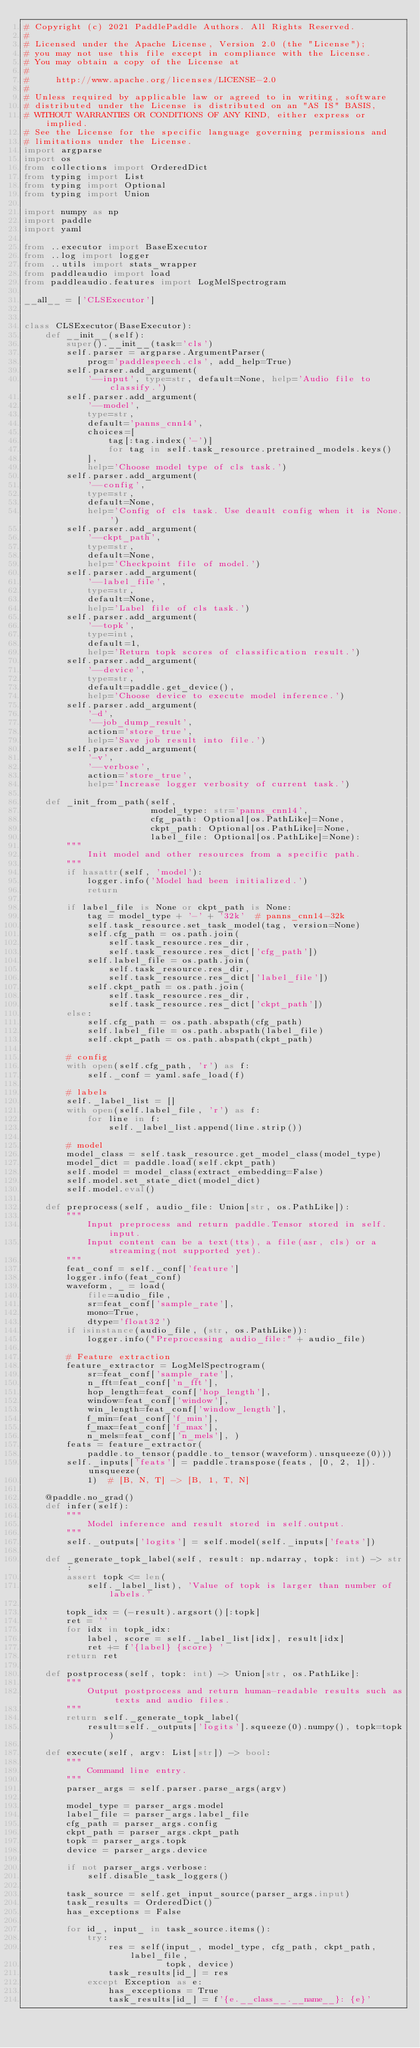<code> <loc_0><loc_0><loc_500><loc_500><_Python_># Copyright (c) 2021 PaddlePaddle Authors. All Rights Reserved.
#
# Licensed under the Apache License, Version 2.0 (the "License");
# you may not use this file except in compliance with the License.
# You may obtain a copy of the License at
#
#     http://www.apache.org/licenses/LICENSE-2.0
#
# Unless required by applicable law or agreed to in writing, software
# distributed under the License is distributed on an "AS IS" BASIS,
# WITHOUT WARRANTIES OR CONDITIONS OF ANY KIND, either express or implied.
# See the License for the specific language governing permissions and
# limitations under the License.
import argparse
import os
from collections import OrderedDict
from typing import List
from typing import Optional
from typing import Union

import numpy as np
import paddle
import yaml

from ..executor import BaseExecutor
from ..log import logger
from ..utils import stats_wrapper
from paddleaudio import load
from paddleaudio.features import LogMelSpectrogram

__all__ = ['CLSExecutor']


class CLSExecutor(BaseExecutor):
    def __init__(self):
        super().__init__(task='cls')
        self.parser = argparse.ArgumentParser(
            prog='paddlespeech.cls', add_help=True)
        self.parser.add_argument(
            '--input', type=str, default=None, help='Audio file to classify.')
        self.parser.add_argument(
            '--model',
            type=str,
            default='panns_cnn14',
            choices=[
                tag[:tag.index('-')]
                for tag in self.task_resource.pretrained_models.keys()
            ],
            help='Choose model type of cls task.')
        self.parser.add_argument(
            '--config',
            type=str,
            default=None,
            help='Config of cls task. Use deault config when it is None.')
        self.parser.add_argument(
            '--ckpt_path',
            type=str,
            default=None,
            help='Checkpoint file of model.')
        self.parser.add_argument(
            '--label_file',
            type=str,
            default=None,
            help='Label file of cls task.')
        self.parser.add_argument(
            '--topk',
            type=int,
            default=1,
            help='Return topk scores of classification result.')
        self.parser.add_argument(
            '--device',
            type=str,
            default=paddle.get_device(),
            help='Choose device to execute model inference.')
        self.parser.add_argument(
            '-d',
            '--job_dump_result',
            action='store_true',
            help='Save job result into file.')
        self.parser.add_argument(
            '-v',
            '--verbose',
            action='store_true',
            help='Increase logger verbosity of current task.')

    def _init_from_path(self,
                        model_type: str='panns_cnn14',
                        cfg_path: Optional[os.PathLike]=None,
                        ckpt_path: Optional[os.PathLike]=None,
                        label_file: Optional[os.PathLike]=None):
        """
            Init model and other resources from a specific path.
        """
        if hasattr(self, 'model'):
            logger.info('Model had been initialized.')
            return

        if label_file is None or ckpt_path is None:
            tag = model_type + '-' + '32k'  # panns_cnn14-32k
            self.task_resource.set_task_model(tag, version=None)
            self.cfg_path = os.path.join(
                self.task_resource.res_dir,
                self.task_resource.res_dict['cfg_path'])
            self.label_file = os.path.join(
                self.task_resource.res_dir,
                self.task_resource.res_dict['label_file'])
            self.ckpt_path = os.path.join(
                self.task_resource.res_dir,
                self.task_resource.res_dict['ckpt_path'])
        else:
            self.cfg_path = os.path.abspath(cfg_path)
            self.label_file = os.path.abspath(label_file)
            self.ckpt_path = os.path.abspath(ckpt_path)

        # config
        with open(self.cfg_path, 'r') as f:
            self._conf = yaml.safe_load(f)

        # labels
        self._label_list = []
        with open(self.label_file, 'r') as f:
            for line in f:
                self._label_list.append(line.strip())

        # model
        model_class = self.task_resource.get_model_class(model_type)
        model_dict = paddle.load(self.ckpt_path)
        self.model = model_class(extract_embedding=False)
        self.model.set_state_dict(model_dict)
        self.model.eval()

    def preprocess(self, audio_file: Union[str, os.PathLike]):
        """
            Input preprocess and return paddle.Tensor stored in self.input.
            Input content can be a text(tts), a file(asr, cls) or a streaming(not supported yet).
        """
        feat_conf = self._conf['feature']
        logger.info(feat_conf)
        waveform, _ = load(
            file=audio_file,
            sr=feat_conf['sample_rate'],
            mono=True,
            dtype='float32')
        if isinstance(audio_file, (str, os.PathLike)):
            logger.info("Preprocessing audio_file:" + audio_file)

        # Feature extraction
        feature_extractor = LogMelSpectrogram(
            sr=feat_conf['sample_rate'],
            n_fft=feat_conf['n_fft'],
            hop_length=feat_conf['hop_length'],
            window=feat_conf['window'],
            win_length=feat_conf['window_length'],
            f_min=feat_conf['f_min'],
            f_max=feat_conf['f_max'],
            n_mels=feat_conf['n_mels'], )
        feats = feature_extractor(
            paddle.to_tensor(paddle.to_tensor(waveform).unsqueeze(0)))
        self._inputs['feats'] = paddle.transpose(feats, [0, 2, 1]).unsqueeze(
            1)  # [B, N, T] -> [B, 1, T, N]

    @paddle.no_grad()
    def infer(self):
        """
            Model inference and result stored in self.output.
        """
        self._outputs['logits'] = self.model(self._inputs['feats'])

    def _generate_topk_label(self, result: np.ndarray, topk: int) -> str:
        assert topk <= len(
            self._label_list), 'Value of topk is larger than number of labels.'

        topk_idx = (-result).argsort()[:topk]
        ret = ''
        for idx in topk_idx:
            label, score = self._label_list[idx], result[idx]
            ret += f'{label} {score} '
        return ret

    def postprocess(self, topk: int) -> Union[str, os.PathLike]:
        """
            Output postprocess and return human-readable results such as texts and audio files.
        """
        return self._generate_topk_label(
            result=self._outputs['logits'].squeeze(0).numpy(), topk=topk)

    def execute(self, argv: List[str]) -> bool:
        """
            Command line entry.
        """
        parser_args = self.parser.parse_args(argv)

        model_type = parser_args.model
        label_file = parser_args.label_file
        cfg_path = parser_args.config
        ckpt_path = parser_args.ckpt_path
        topk = parser_args.topk
        device = parser_args.device

        if not parser_args.verbose:
            self.disable_task_loggers()

        task_source = self.get_input_source(parser_args.input)
        task_results = OrderedDict()
        has_exceptions = False

        for id_, input_ in task_source.items():
            try:
                res = self(input_, model_type, cfg_path, ckpt_path, label_file,
                           topk, device)
                task_results[id_] = res
            except Exception as e:
                has_exceptions = True
                task_results[id_] = f'{e.__class__.__name__}: {e}'
</code> 